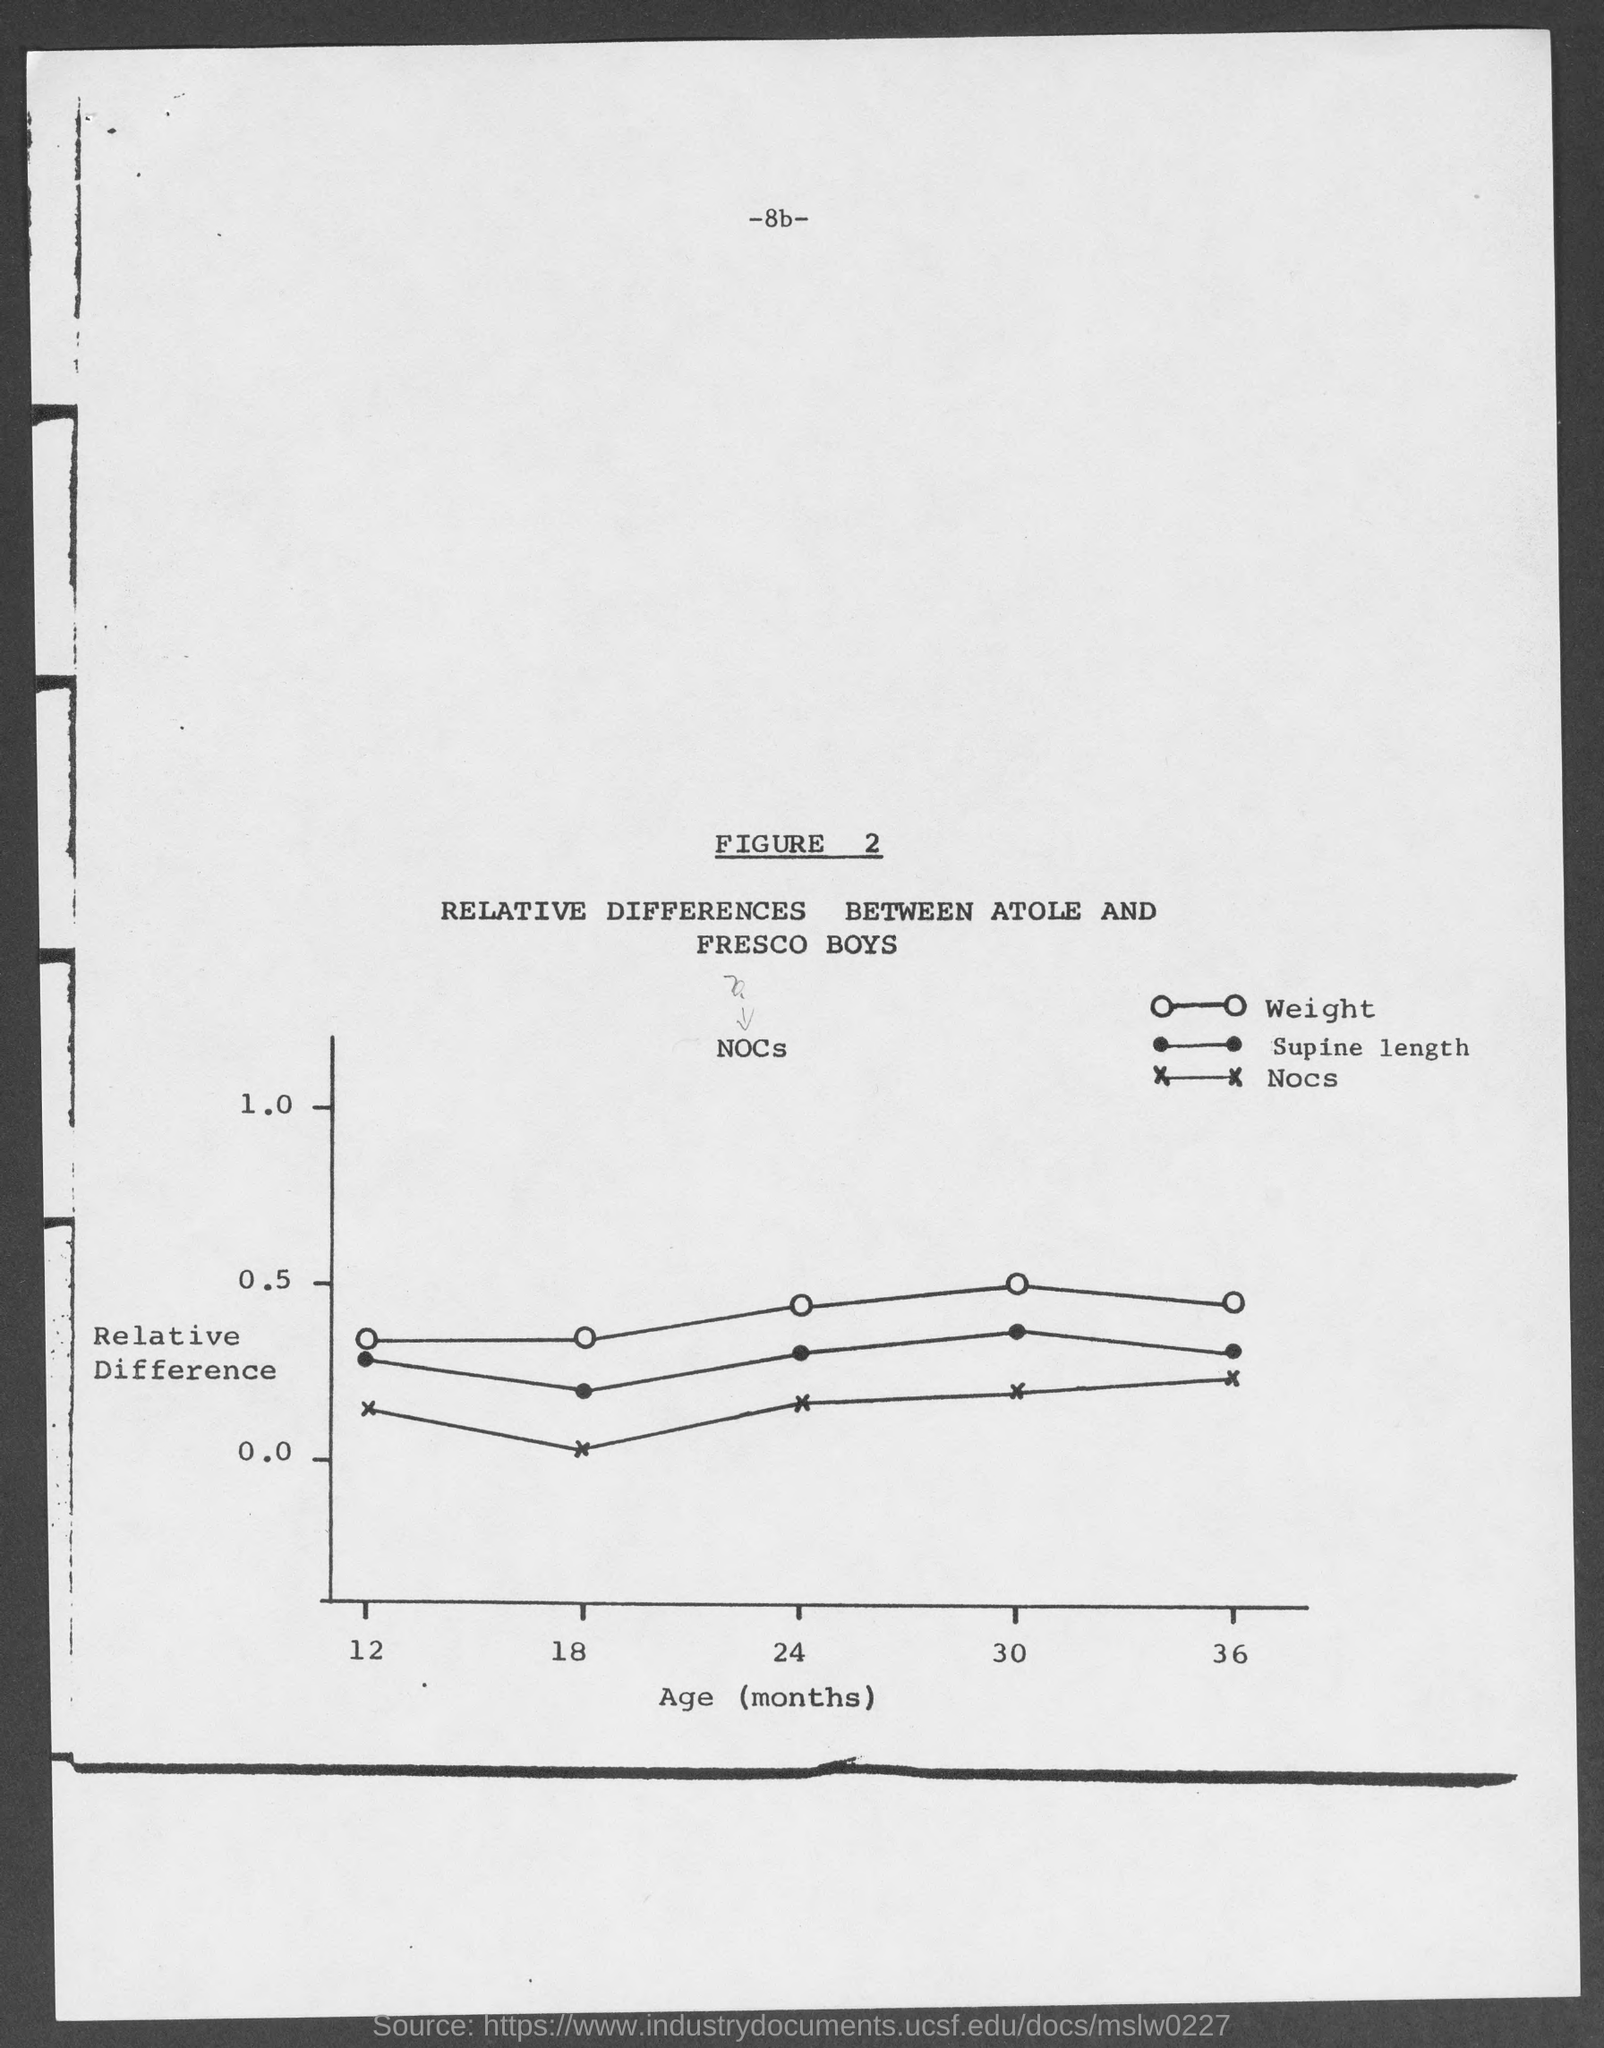Point out several critical features in this image. The x-axis of the graph represents the age of the patients (measured in months). Figure 2 represents the relative differences between the Atoles and Fresco Boys, a group of young people who have gained popularity on social media platforms such as TikTok and Instagram. The Y-axis of the graph represents the relative difference between two values. The page number mentioned in this document is 8b. 